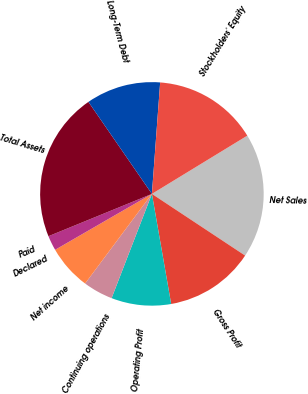Convert chart. <chart><loc_0><loc_0><loc_500><loc_500><pie_chart><fcel>Net Sales<fcel>Gross Profit<fcel>Operating Profit<fcel>Continuing operations<fcel>Net income<fcel>Declared<fcel>Paid<fcel>Total Assets<fcel>Long-Term Debt<fcel>Stockholders' Equity<nl><fcel>18.03%<fcel>12.94%<fcel>8.63%<fcel>4.32%<fcel>6.47%<fcel>2.16%<fcel>0.0%<fcel>21.57%<fcel>10.79%<fcel>15.1%<nl></chart> 